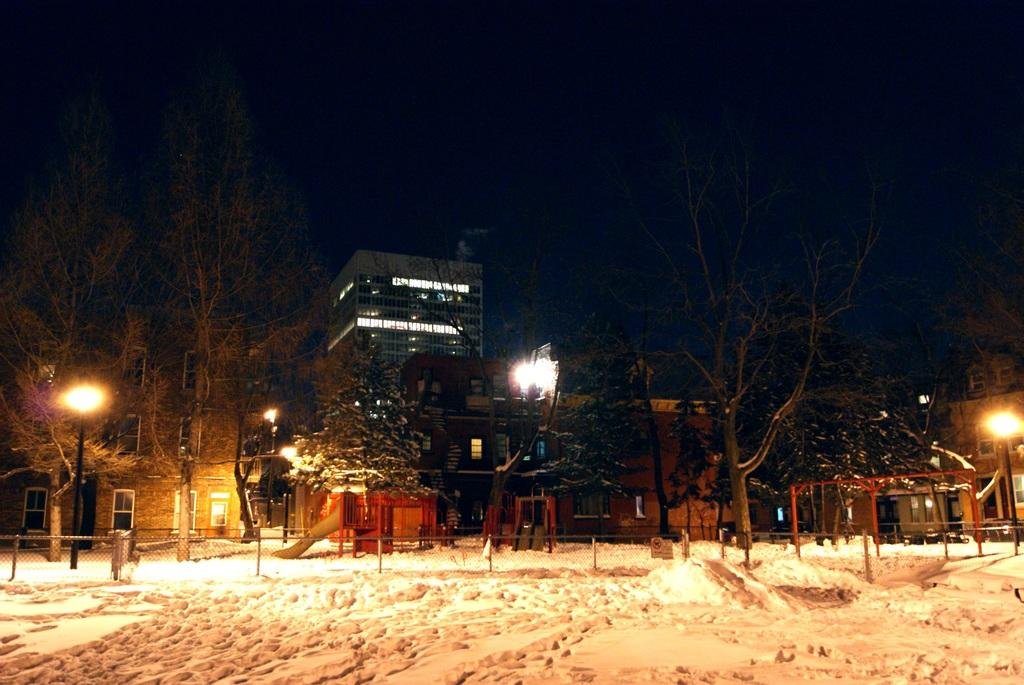What type of structures can be seen in the image? There are buildings in the image. What natural elements are present in the image? There are trees in the image. What man-made objects can be seen along the street? Street poles and street lights are visible in the image. What type of barriers are present in the image? Fences and barrier poles are in the image. What part of the natural environment is visible in the image? The sky is visible in the image. How is the road affected by the weather in the image? The road is covered with snow in the foreground of the image. What type of amusement can be seen in the image? There is no amusement present in the image; it features buildings, trees, street poles, street lights, fences, barrier poles, the sky, and a snow-covered road. What type of collar is visible on the trees in the image? There are no collars present on the trees in the image; they are natural trees. 